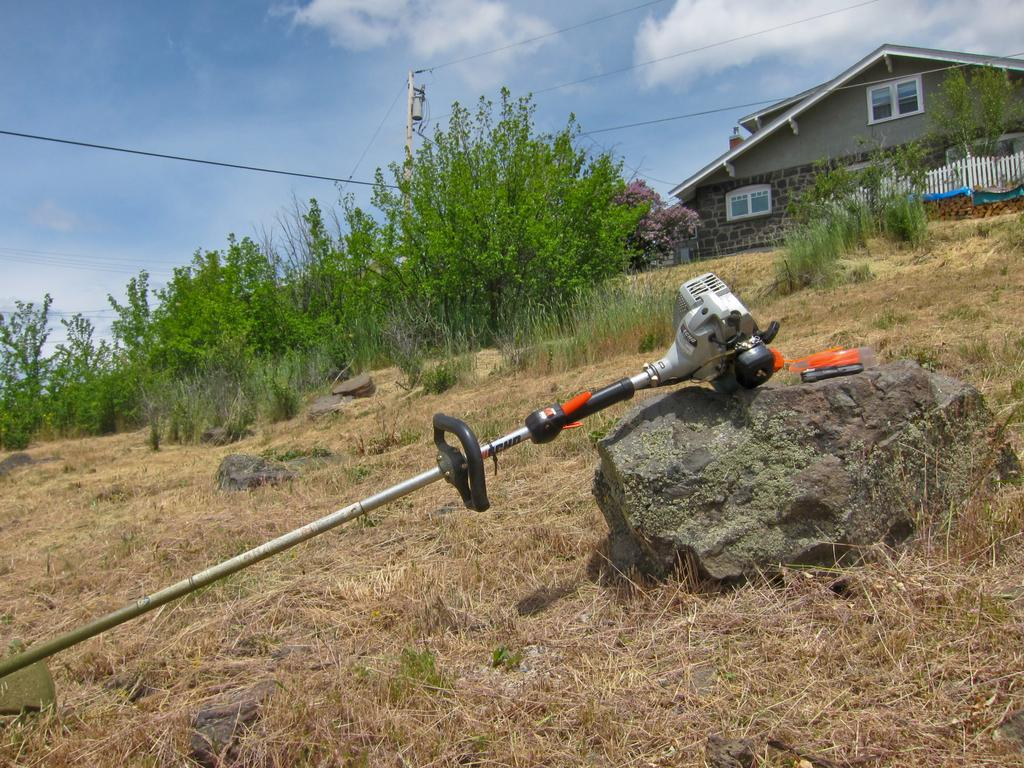What is the main object in the image? There is a rod with a device on it in the image. What is the rod placed on? The rod is on a stone. What type of natural environment is visible in the image? There are stones, grass, plants, and the sky visible in the image. What structures can be seen in the background of the image? There is a house, a wall, windows, a pole, a fence, and wires visible in the background of the image. What type of disease is being treated by the device on the rod in the image? There is no indication of a disease or medical treatment in the image; it simply shows a rod with a device on it. Where is the library located in the image? There is no library present in the image. 